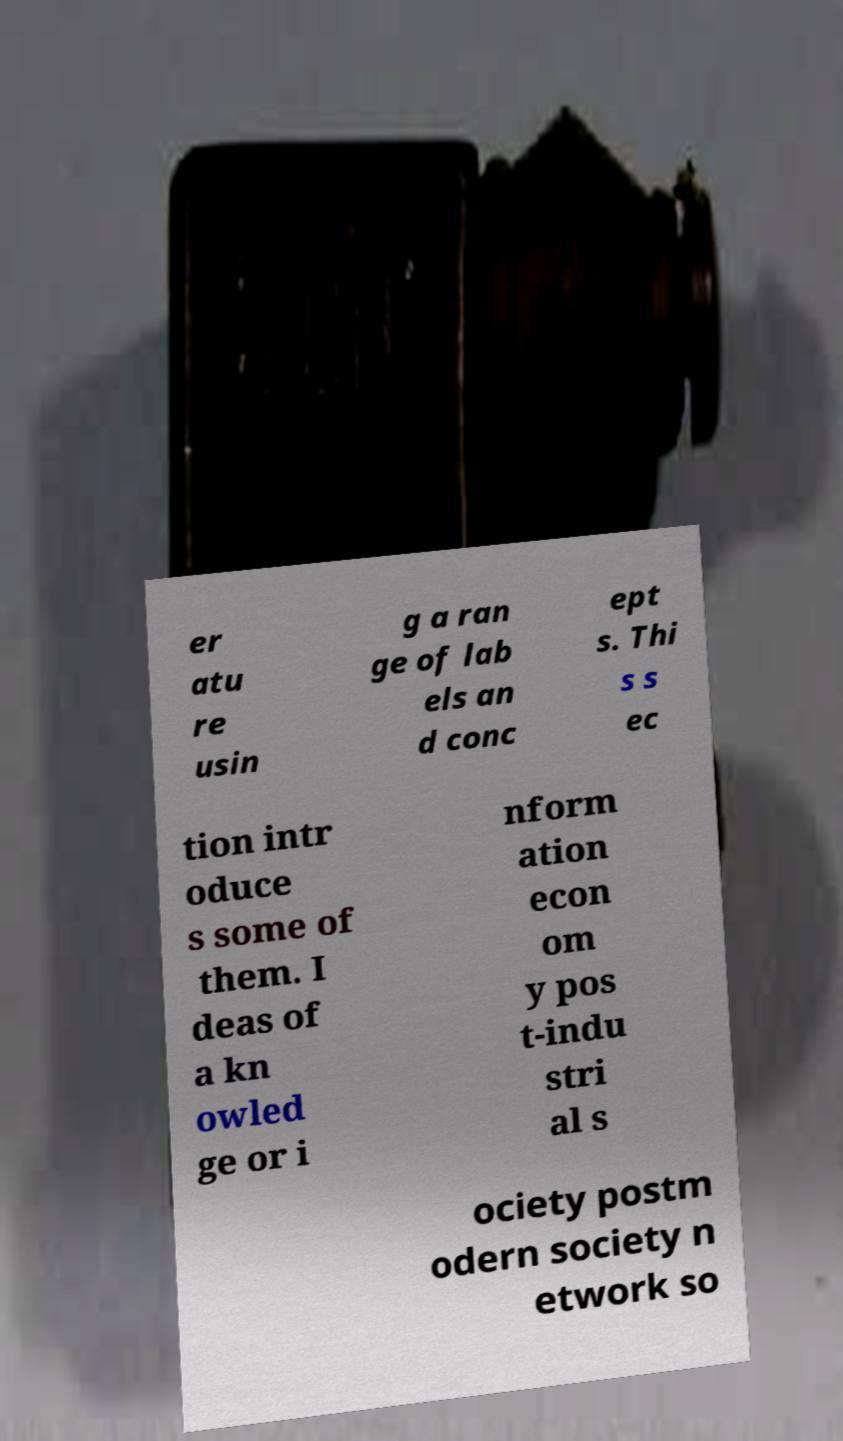Can you read and provide the text displayed in the image?This photo seems to have some interesting text. Can you extract and type it out for me? er atu re usin g a ran ge of lab els an d conc ept s. Thi s s ec tion intr oduce s some of them. I deas of a kn owled ge or i nform ation econ om y pos t-indu stri al s ociety postm odern society n etwork so 